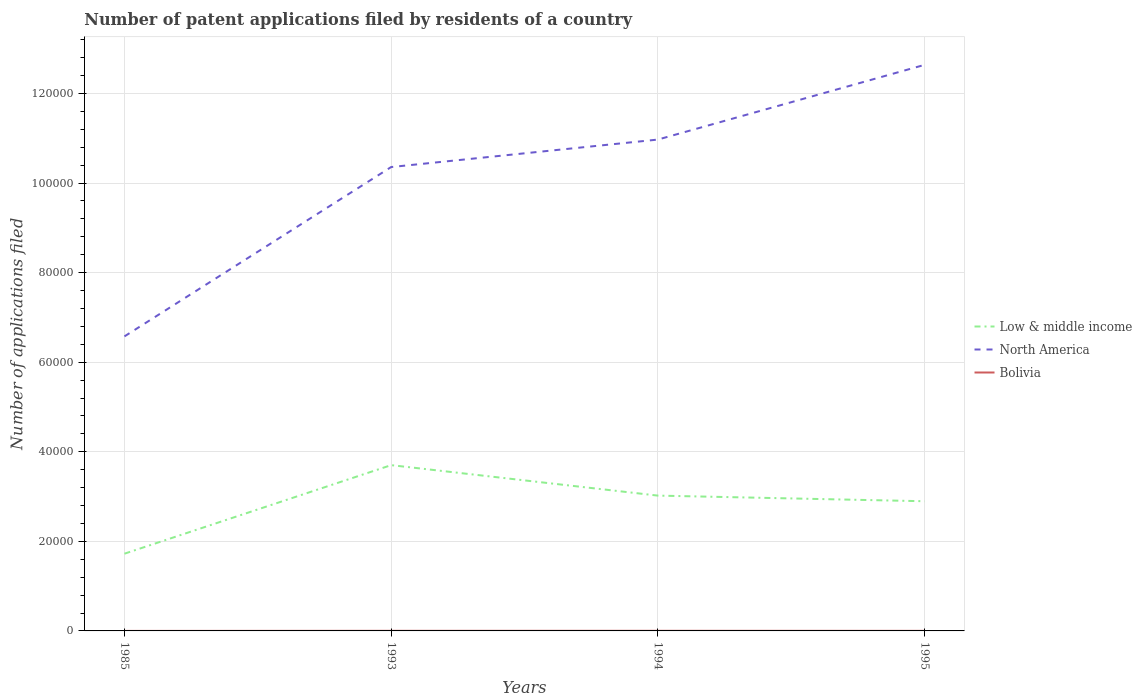Does the line corresponding to Bolivia intersect with the line corresponding to Low & middle income?
Give a very brief answer. No. Is the number of lines equal to the number of legend labels?
Your response must be concise. Yes. Across all years, what is the maximum number of applications filed in Low & middle income?
Offer a very short reply. 1.72e+04. In which year was the number of applications filed in North America maximum?
Provide a succinct answer. 1985. What is the difference between the highest and the second highest number of applications filed in Low & middle income?
Your answer should be very brief. 1.98e+04. How many lines are there?
Keep it short and to the point. 3. How many years are there in the graph?
Ensure brevity in your answer.  4. What is the difference between two consecutive major ticks on the Y-axis?
Give a very brief answer. 2.00e+04. Are the values on the major ticks of Y-axis written in scientific E-notation?
Provide a short and direct response. No. Where does the legend appear in the graph?
Provide a succinct answer. Center right. How are the legend labels stacked?
Make the answer very short. Vertical. What is the title of the graph?
Give a very brief answer. Number of patent applications filed by residents of a country. Does "Northern Mariana Islands" appear as one of the legend labels in the graph?
Provide a succinct answer. No. What is the label or title of the Y-axis?
Provide a succinct answer. Number of applications filed. What is the Number of applications filed in Low & middle income in 1985?
Provide a succinct answer. 1.72e+04. What is the Number of applications filed in North America in 1985?
Keep it short and to the point. 6.58e+04. What is the Number of applications filed in Bolivia in 1985?
Provide a short and direct response. 5. What is the Number of applications filed of Low & middle income in 1993?
Provide a succinct answer. 3.70e+04. What is the Number of applications filed of North America in 1993?
Your response must be concise. 1.04e+05. What is the Number of applications filed of Low & middle income in 1994?
Provide a succinct answer. 3.02e+04. What is the Number of applications filed in North America in 1994?
Your answer should be compact. 1.10e+05. What is the Number of applications filed of Bolivia in 1994?
Your answer should be very brief. 28. What is the Number of applications filed in Low & middle income in 1995?
Provide a succinct answer. 2.90e+04. What is the Number of applications filed of North America in 1995?
Offer a very short reply. 1.26e+05. Across all years, what is the maximum Number of applications filed in Low & middle income?
Offer a terse response. 3.70e+04. Across all years, what is the maximum Number of applications filed in North America?
Your response must be concise. 1.26e+05. Across all years, what is the maximum Number of applications filed in Bolivia?
Give a very brief answer. 28. Across all years, what is the minimum Number of applications filed in Low & middle income?
Keep it short and to the point. 1.72e+04. Across all years, what is the minimum Number of applications filed of North America?
Keep it short and to the point. 6.58e+04. Across all years, what is the minimum Number of applications filed in Bolivia?
Give a very brief answer. 5. What is the total Number of applications filed in Low & middle income in the graph?
Your answer should be compact. 1.13e+05. What is the total Number of applications filed of North America in the graph?
Keep it short and to the point. 4.05e+05. What is the difference between the Number of applications filed of Low & middle income in 1985 and that in 1993?
Provide a succinct answer. -1.98e+04. What is the difference between the Number of applications filed in North America in 1985 and that in 1993?
Ensure brevity in your answer.  -3.78e+04. What is the difference between the Number of applications filed of Bolivia in 1985 and that in 1993?
Your answer should be compact. -21. What is the difference between the Number of applications filed in Low & middle income in 1985 and that in 1994?
Make the answer very short. -1.30e+04. What is the difference between the Number of applications filed in North America in 1985 and that in 1994?
Your answer should be very brief. -4.39e+04. What is the difference between the Number of applications filed in Low & middle income in 1985 and that in 1995?
Offer a terse response. -1.17e+04. What is the difference between the Number of applications filed of North America in 1985 and that in 1995?
Offer a very short reply. -6.06e+04. What is the difference between the Number of applications filed in Bolivia in 1985 and that in 1995?
Provide a short and direct response. -12. What is the difference between the Number of applications filed in Low & middle income in 1993 and that in 1994?
Offer a terse response. 6803. What is the difference between the Number of applications filed in North America in 1993 and that in 1994?
Your response must be concise. -6135. What is the difference between the Number of applications filed of Low & middle income in 1993 and that in 1995?
Your response must be concise. 8062. What is the difference between the Number of applications filed of North America in 1993 and that in 1995?
Offer a terse response. -2.28e+04. What is the difference between the Number of applications filed in Low & middle income in 1994 and that in 1995?
Your response must be concise. 1259. What is the difference between the Number of applications filed in North America in 1994 and that in 1995?
Offer a terse response. -1.67e+04. What is the difference between the Number of applications filed of Low & middle income in 1985 and the Number of applications filed of North America in 1993?
Give a very brief answer. -8.63e+04. What is the difference between the Number of applications filed in Low & middle income in 1985 and the Number of applications filed in Bolivia in 1993?
Ensure brevity in your answer.  1.72e+04. What is the difference between the Number of applications filed in North America in 1985 and the Number of applications filed in Bolivia in 1993?
Offer a very short reply. 6.57e+04. What is the difference between the Number of applications filed in Low & middle income in 1985 and the Number of applications filed in North America in 1994?
Provide a succinct answer. -9.25e+04. What is the difference between the Number of applications filed of Low & middle income in 1985 and the Number of applications filed of Bolivia in 1994?
Offer a terse response. 1.72e+04. What is the difference between the Number of applications filed of North America in 1985 and the Number of applications filed of Bolivia in 1994?
Provide a short and direct response. 6.57e+04. What is the difference between the Number of applications filed of Low & middle income in 1985 and the Number of applications filed of North America in 1995?
Make the answer very short. -1.09e+05. What is the difference between the Number of applications filed of Low & middle income in 1985 and the Number of applications filed of Bolivia in 1995?
Provide a short and direct response. 1.72e+04. What is the difference between the Number of applications filed of North America in 1985 and the Number of applications filed of Bolivia in 1995?
Your response must be concise. 6.57e+04. What is the difference between the Number of applications filed in Low & middle income in 1993 and the Number of applications filed in North America in 1994?
Ensure brevity in your answer.  -7.27e+04. What is the difference between the Number of applications filed in Low & middle income in 1993 and the Number of applications filed in Bolivia in 1994?
Your answer should be compact. 3.70e+04. What is the difference between the Number of applications filed of North America in 1993 and the Number of applications filed of Bolivia in 1994?
Give a very brief answer. 1.04e+05. What is the difference between the Number of applications filed of Low & middle income in 1993 and the Number of applications filed of North America in 1995?
Make the answer very short. -8.94e+04. What is the difference between the Number of applications filed of Low & middle income in 1993 and the Number of applications filed of Bolivia in 1995?
Ensure brevity in your answer.  3.70e+04. What is the difference between the Number of applications filed of North America in 1993 and the Number of applications filed of Bolivia in 1995?
Offer a terse response. 1.04e+05. What is the difference between the Number of applications filed of Low & middle income in 1994 and the Number of applications filed of North America in 1995?
Give a very brief answer. -9.62e+04. What is the difference between the Number of applications filed in Low & middle income in 1994 and the Number of applications filed in Bolivia in 1995?
Provide a succinct answer. 3.02e+04. What is the difference between the Number of applications filed of North America in 1994 and the Number of applications filed of Bolivia in 1995?
Your answer should be very brief. 1.10e+05. What is the average Number of applications filed in Low & middle income per year?
Provide a succinct answer. 2.84e+04. What is the average Number of applications filed in North America per year?
Your response must be concise. 1.01e+05. In the year 1985, what is the difference between the Number of applications filed of Low & middle income and Number of applications filed of North America?
Keep it short and to the point. -4.85e+04. In the year 1985, what is the difference between the Number of applications filed in Low & middle income and Number of applications filed in Bolivia?
Ensure brevity in your answer.  1.72e+04. In the year 1985, what is the difference between the Number of applications filed in North America and Number of applications filed in Bolivia?
Your response must be concise. 6.58e+04. In the year 1993, what is the difference between the Number of applications filed of Low & middle income and Number of applications filed of North America?
Provide a succinct answer. -6.66e+04. In the year 1993, what is the difference between the Number of applications filed in Low & middle income and Number of applications filed in Bolivia?
Provide a short and direct response. 3.70e+04. In the year 1993, what is the difference between the Number of applications filed in North America and Number of applications filed in Bolivia?
Provide a succinct answer. 1.04e+05. In the year 1994, what is the difference between the Number of applications filed of Low & middle income and Number of applications filed of North America?
Your answer should be very brief. -7.95e+04. In the year 1994, what is the difference between the Number of applications filed of Low & middle income and Number of applications filed of Bolivia?
Provide a short and direct response. 3.02e+04. In the year 1994, what is the difference between the Number of applications filed of North America and Number of applications filed of Bolivia?
Give a very brief answer. 1.10e+05. In the year 1995, what is the difference between the Number of applications filed of Low & middle income and Number of applications filed of North America?
Your answer should be very brief. -9.74e+04. In the year 1995, what is the difference between the Number of applications filed of Low & middle income and Number of applications filed of Bolivia?
Provide a short and direct response. 2.89e+04. In the year 1995, what is the difference between the Number of applications filed of North America and Number of applications filed of Bolivia?
Provide a succinct answer. 1.26e+05. What is the ratio of the Number of applications filed of Low & middle income in 1985 to that in 1993?
Keep it short and to the point. 0.47. What is the ratio of the Number of applications filed in North America in 1985 to that in 1993?
Make the answer very short. 0.63. What is the ratio of the Number of applications filed in Bolivia in 1985 to that in 1993?
Your response must be concise. 0.19. What is the ratio of the Number of applications filed of Low & middle income in 1985 to that in 1994?
Your answer should be very brief. 0.57. What is the ratio of the Number of applications filed of North America in 1985 to that in 1994?
Ensure brevity in your answer.  0.6. What is the ratio of the Number of applications filed in Bolivia in 1985 to that in 1994?
Provide a short and direct response. 0.18. What is the ratio of the Number of applications filed of Low & middle income in 1985 to that in 1995?
Offer a very short reply. 0.6. What is the ratio of the Number of applications filed of North America in 1985 to that in 1995?
Ensure brevity in your answer.  0.52. What is the ratio of the Number of applications filed of Bolivia in 1985 to that in 1995?
Your answer should be compact. 0.29. What is the ratio of the Number of applications filed of Low & middle income in 1993 to that in 1994?
Provide a short and direct response. 1.23. What is the ratio of the Number of applications filed of North America in 1993 to that in 1994?
Your response must be concise. 0.94. What is the ratio of the Number of applications filed in Low & middle income in 1993 to that in 1995?
Give a very brief answer. 1.28. What is the ratio of the Number of applications filed of North America in 1993 to that in 1995?
Give a very brief answer. 0.82. What is the ratio of the Number of applications filed of Bolivia in 1993 to that in 1995?
Make the answer very short. 1.53. What is the ratio of the Number of applications filed in Low & middle income in 1994 to that in 1995?
Give a very brief answer. 1.04. What is the ratio of the Number of applications filed of North America in 1994 to that in 1995?
Keep it short and to the point. 0.87. What is the ratio of the Number of applications filed of Bolivia in 1994 to that in 1995?
Your answer should be compact. 1.65. What is the difference between the highest and the second highest Number of applications filed of Low & middle income?
Your response must be concise. 6803. What is the difference between the highest and the second highest Number of applications filed of North America?
Provide a short and direct response. 1.67e+04. What is the difference between the highest and the lowest Number of applications filed in Low & middle income?
Your answer should be very brief. 1.98e+04. What is the difference between the highest and the lowest Number of applications filed in North America?
Provide a short and direct response. 6.06e+04. What is the difference between the highest and the lowest Number of applications filed of Bolivia?
Give a very brief answer. 23. 